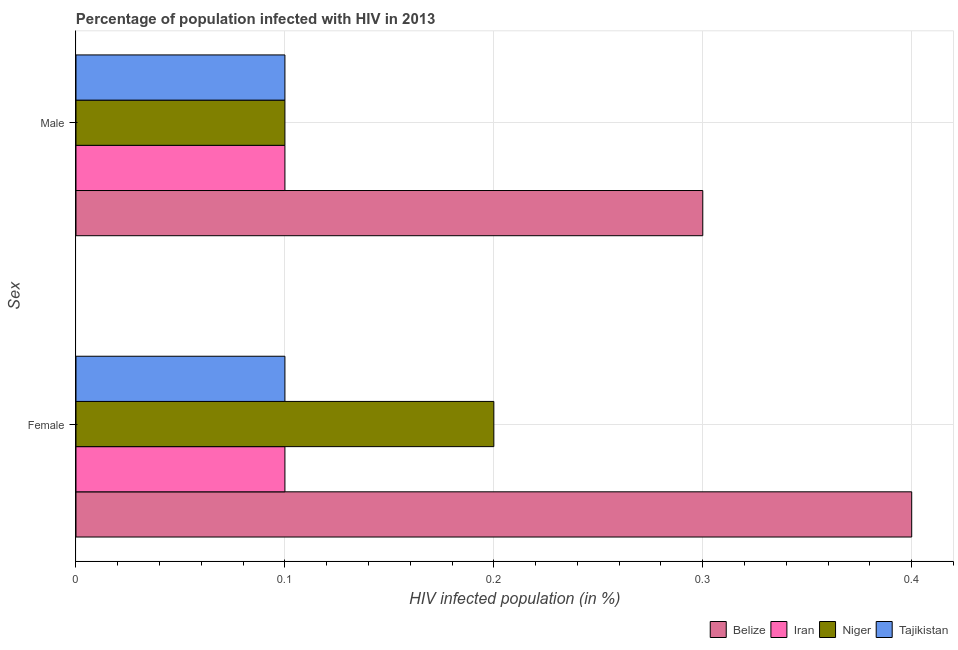How many different coloured bars are there?
Keep it short and to the point. 4. Are the number of bars per tick equal to the number of legend labels?
Provide a short and direct response. Yes. Across all countries, what is the maximum percentage of males who are infected with hiv?
Provide a short and direct response. 0.3. In which country was the percentage of males who are infected with hiv maximum?
Ensure brevity in your answer.  Belize. In which country was the percentage of males who are infected with hiv minimum?
Keep it short and to the point. Iran. What is the total percentage of females who are infected with hiv in the graph?
Ensure brevity in your answer.  0.8. What is the difference between the percentage of females who are infected with hiv in Tajikistan and the percentage of males who are infected with hiv in Belize?
Give a very brief answer. -0.2. What is the average percentage of females who are infected with hiv per country?
Offer a very short reply. 0.2. In how many countries, is the percentage of males who are infected with hiv greater than 0.2 %?
Provide a succinct answer. 1. What is the ratio of the percentage of females who are infected with hiv in Iran to that in Tajikistan?
Ensure brevity in your answer.  1. In how many countries, is the percentage of females who are infected with hiv greater than the average percentage of females who are infected with hiv taken over all countries?
Give a very brief answer. 2. What does the 4th bar from the top in Male represents?
Provide a succinct answer. Belize. What does the 1st bar from the bottom in Female represents?
Your response must be concise. Belize. How many bars are there?
Ensure brevity in your answer.  8. Are all the bars in the graph horizontal?
Your answer should be very brief. Yes. What is the difference between two consecutive major ticks on the X-axis?
Give a very brief answer. 0.1. Does the graph contain any zero values?
Your response must be concise. No. Does the graph contain grids?
Offer a very short reply. Yes. What is the title of the graph?
Offer a very short reply. Percentage of population infected with HIV in 2013. What is the label or title of the X-axis?
Make the answer very short. HIV infected population (in %). What is the label or title of the Y-axis?
Give a very brief answer. Sex. What is the HIV infected population (in %) in Iran in Female?
Your answer should be compact. 0.1. What is the HIV infected population (in %) in Tajikistan in Female?
Your response must be concise. 0.1. What is the HIV infected population (in %) in Iran in Male?
Provide a short and direct response. 0.1. What is the HIV infected population (in %) of Tajikistan in Male?
Offer a terse response. 0.1. Across all Sex, what is the maximum HIV infected population (in %) of Belize?
Make the answer very short. 0.4. Across all Sex, what is the maximum HIV infected population (in %) of Iran?
Your response must be concise. 0.1. Across all Sex, what is the maximum HIV infected population (in %) in Niger?
Offer a very short reply. 0.2. Across all Sex, what is the maximum HIV infected population (in %) of Tajikistan?
Give a very brief answer. 0.1. Across all Sex, what is the minimum HIV infected population (in %) of Belize?
Ensure brevity in your answer.  0.3. Across all Sex, what is the minimum HIV infected population (in %) in Iran?
Your answer should be compact. 0.1. Across all Sex, what is the minimum HIV infected population (in %) of Niger?
Offer a terse response. 0.1. What is the total HIV infected population (in %) in Belize in the graph?
Your response must be concise. 0.7. What is the total HIV infected population (in %) in Niger in the graph?
Offer a very short reply. 0.3. What is the difference between the HIV infected population (in %) of Belize in Female and that in Male?
Your response must be concise. 0.1. What is the difference between the HIV infected population (in %) of Iran in Female and that in Male?
Your response must be concise. 0. What is the difference between the HIV infected population (in %) in Niger in Female and that in Male?
Provide a short and direct response. 0.1. What is the difference between the HIV infected population (in %) in Tajikistan in Female and that in Male?
Provide a short and direct response. 0. What is the difference between the HIV infected population (in %) in Belize in Female and the HIV infected population (in %) in Iran in Male?
Offer a very short reply. 0.3. What is the difference between the HIV infected population (in %) of Iran in Female and the HIV infected population (in %) of Tajikistan in Male?
Provide a short and direct response. 0. What is the average HIV infected population (in %) in Belize per Sex?
Make the answer very short. 0.35. What is the average HIV infected population (in %) of Iran per Sex?
Give a very brief answer. 0.1. What is the average HIV infected population (in %) in Niger per Sex?
Provide a succinct answer. 0.15. What is the difference between the HIV infected population (in %) of Belize and HIV infected population (in %) of Tajikistan in Female?
Your answer should be very brief. 0.3. What is the difference between the HIV infected population (in %) of Iran and HIV infected population (in %) of Niger in Female?
Provide a succinct answer. -0.1. What is the difference between the HIV infected population (in %) in Iran and HIV infected population (in %) in Tajikistan in Female?
Your answer should be compact. 0. What is the difference between the HIV infected population (in %) of Iran and HIV infected population (in %) of Tajikistan in Male?
Ensure brevity in your answer.  0. What is the ratio of the HIV infected population (in %) in Belize in Female to that in Male?
Give a very brief answer. 1.33. What is the ratio of the HIV infected population (in %) in Iran in Female to that in Male?
Your answer should be compact. 1. What is the ratio of the HIV infected population (in %) of Niger in Female to that in Male?
Your answer should be very brief. 2. What is the difference between the highest and the lowest HIV infected population (in %) in Iran?
Provide a short and direct response. 0. What is the difference between the highest and the lowest HIV infected population (in %) in Tajikistan?
Keep it short and to the point. 0. 